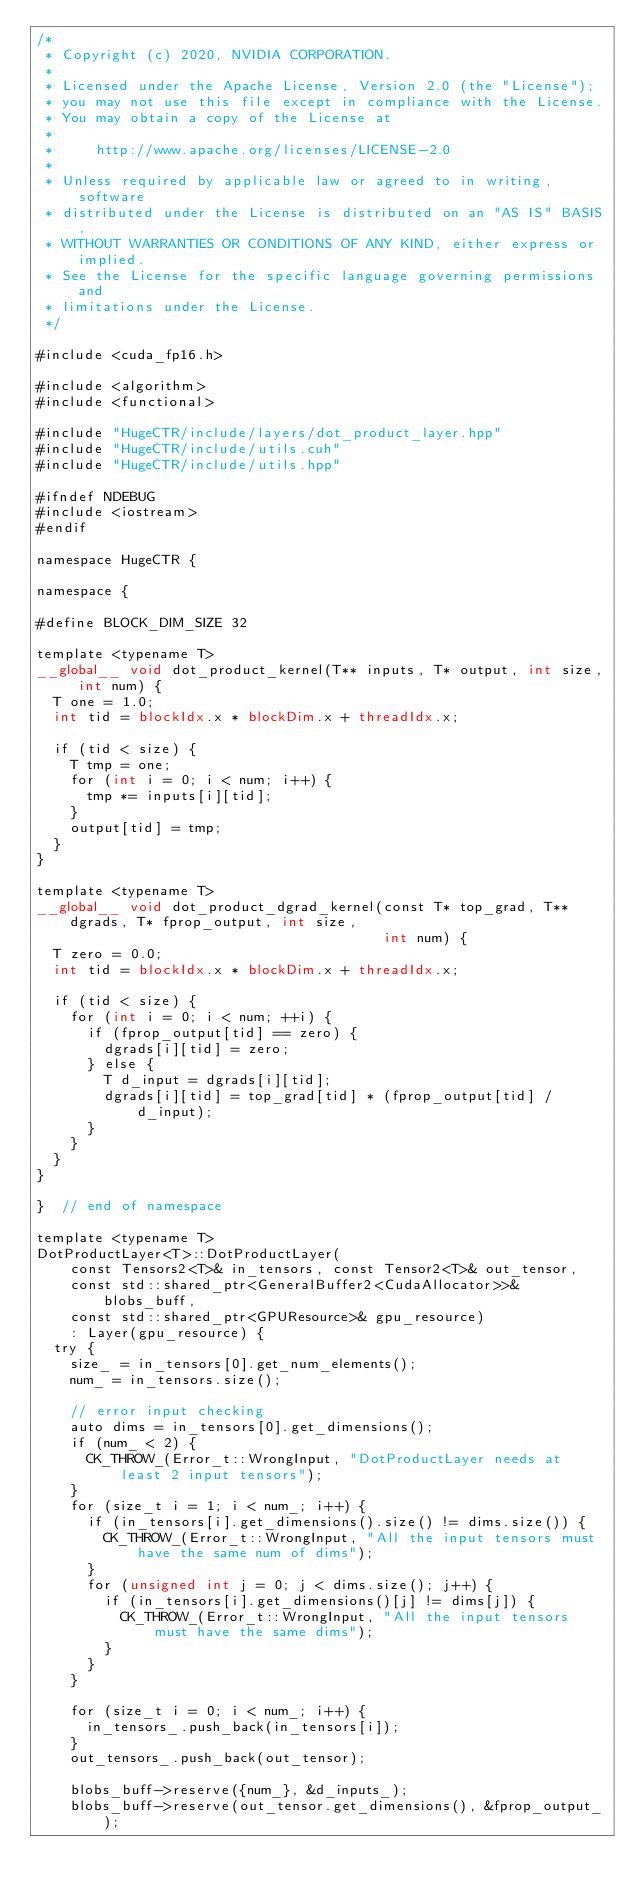<code> <loc_0><loc_0><loc_500><loc_500><_Cuda_>/*
 * Copyright (c) 2020, NVIDIA CORPORATION.
 *
 * Licensed under the Apache License, Version 2.0 (the "License");
 * you may not use this file except in compliance with the License.
 * You may obtain a copy of the License at
 *
 *     http://www.apache.org/licenses/LICENSE-2.0
 *
 * Unless required by applicable law or agreed to in writing, software
 * distributed under the License is distributed on an "AS IS" BASIS,
 * WITHOUT WARRANTIES OR CONDITIONS OF ANY KIND, either express or implied.
 * See the License for the specific language governing permissions and
 * limitations under the License.
 */

#include <cuda_fp16.h>

#include <algorithm>
#include <functional>

#include "HugeCTR/include/layers/dot_product_layer.hpp"
#include "HugeCTR/include/utils.cuh"
#include "HugeCTR/include/utils.hpp"

#ifndef NDEBUG
#include <iostream>
#endif

namespace HugeCTR {

namespace {

#define BLOCK_DIM_SIZE 32

template <typename T>
__global__ void dot_product_kernel(T** inputs, T* output, int size, int num) {
  T one = 1.0;
  int tid = blockIdx.x * blockDim.x + threadIdx.x;

  if (tid < size) {
    T tmp = one;
    for (int i = 0; i < num; i++) {
      tmp *= inputs[i][tid];
    }
    output[tid] = tmp;
  }
}

template <typename T>
__global__ void dot_product_dgrad_kernel(const T* top_grad, T** dgrads, T* fprop_output, int size,
                                         int num) {
  T zero = 0.0;
  int tid = blockIdx.x * blockDim.x + threadIdx.x;

  if (tid < size) {
    for (int i = 0; i < num; ++i) {
      if (fprop_output[tid] == zero) {
        dgrads[i][tid] = zero;
      } else {
        T d_input = dgrads[i][tid];
        dgrads[i][tid] = top_grad[tid] * (fprop_output[tid] / d_input);
      }
    }
  }
}

}  // end of namespace

template <typename T>
DotProductLayer<T>::DotProductLayer(
    const Tensors2<T>& in_tensors, const Tensor2<T>& out_tensor,
    const std::shared_ptr<GeneralBuffer2<CudaAllocator>>& blobs_buff,
    const std::shared_ptr<GPUResource>& gpu_resource)
    : Layer(gpu_resource) {
  try {
    size_ = in_tensors[0].get_num_elements();
    num_ = in_tensors.size();

    // error input checking
    auto dims = in_tensors[0].get_dimensions();
    if (num_ < 2) {
      CK_THROW_(Error_t::WrongInput, "DotProductLayer needs at least 2 input tensors");
    }
    for (size_t i = 1; i < num_; i++) {
      if (in_tensors[i].get_dimensions().size() != dims.size()) {
        CK_THROW_(Error_t::WrongInput, "All the input tensors must have the same num of dims");
      }
      for (unsigned int j = 0; j < dims.size(); j++) {
        if (in_tensors[i].get_dimensions()[j] != dims[j]) {
          CK_THROW_(Error_t::WrongInput, "All the input tensors must have the same dims");
        }
      }
    }

    for (size_t i = 0; i < num_; i++) {
      in_tensors_.push_back(in_tensors[i]);
    }
    out_tensors_.push_back(out_tensor);

    blobs_buff->reserve({num_}, &d_inputs_);
    blobs_buff->reserve(out_tensor.get_dimensions(), &fprop_output_);
</code> 